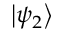<formula> <loc_0><loc_0><loc_500><loc_500>\left | \psi _ { 2 } \right \rangle</formula> 